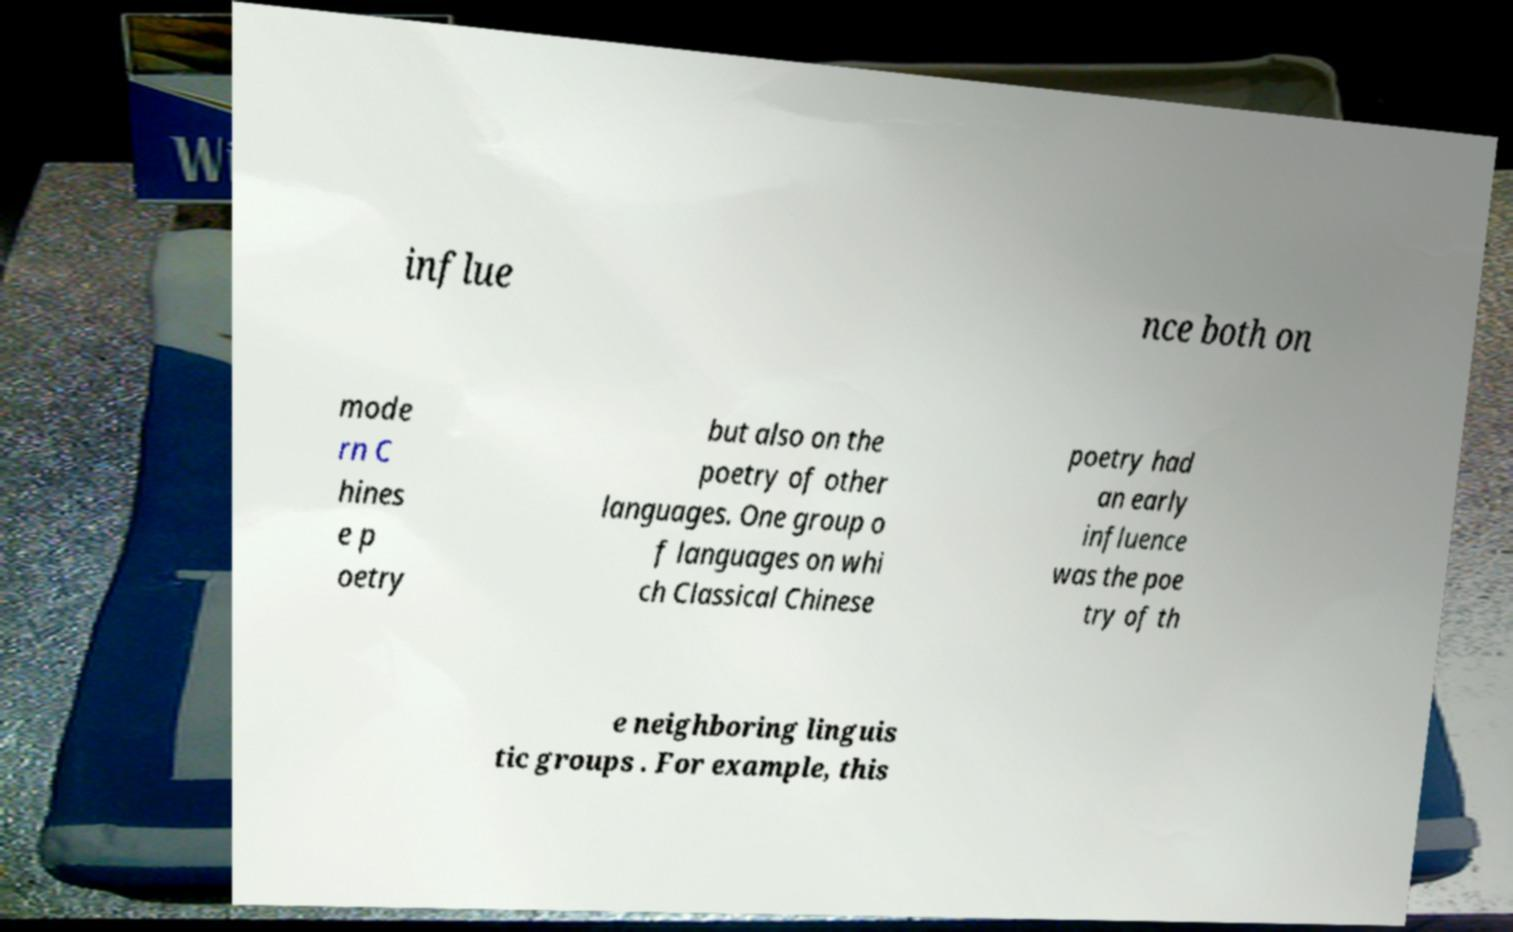What messages or text are displayed in this image? I need them in a readable, typed format. influe nce both on mode rn C hines e p oetry but also on the poetry of other languages. One group o f languages on whi ch Classical Chinese poetry had an early influence was the poe try of th e neighboring linguis tic groups . For example, this 